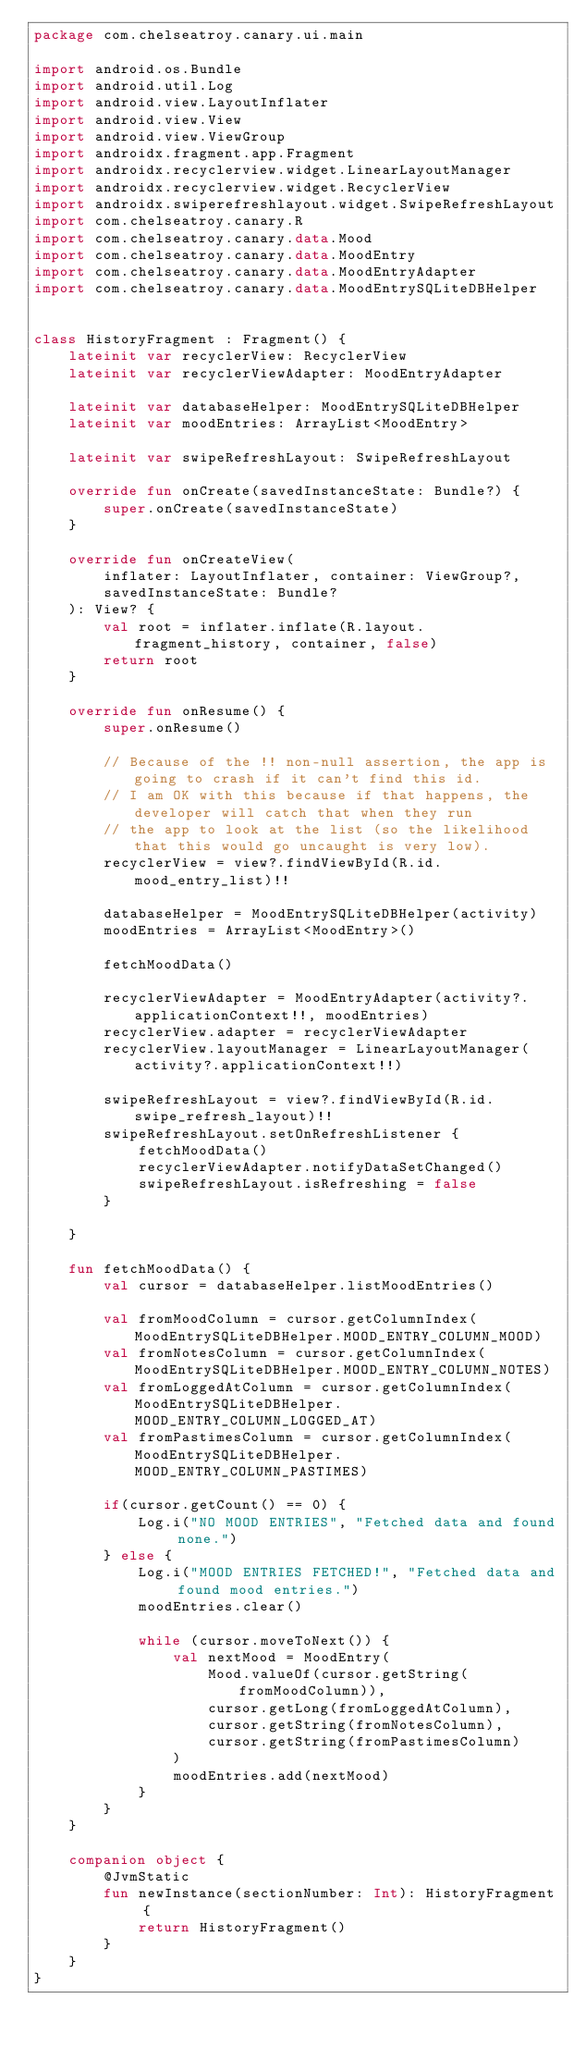<code> <loc_0><loc_0><loc_500><loc_500><_Kotlin_>package com.chelseatroy.canary.ui.main

import android.os.Bundle
import android.util.Log
import android.view.LayoutInflater
import android.view.View
import android.view.ViewGroup
import androidx.fragment.app.Fragment
import androidx.recyclerview.widget.LinearLayoutManager
import androidx.recyclerview.widget.RecyclerView
import androidx.swiperefreshlayout.widget.SwipeRefreshLayout
import com.chelseatroy.canary.R
import com.chelseatroy.canary.data.Mood
import com.chelseatroy.canary.data.MoodEntry
import com.chelseatroy.canary.data.MoodEntryAdapter
import com.chelseatroy.canary.data.MoodEntrySQLiteDBHelper


class HistoryFragment : Fragment() {
    lateinit var recyclerView: RecyclerView
    lateinit var recyclerViewAdapter: MoodEntryAdapter

    lateinit var databaseHelper: MoodEntrySQLiteDBHelper
    lateinit var moodEntries: ArrayList<MoodEntry>

    lateinit var swipeRefreshLayout: SwipeRefreshLayout

    override fun onCreate(savedInstanceState: Bundle?) {
        super.onCreate(savedInstanceState)
    }

    override fun onCreateView(
        inflater: LayoutInflater, container: ViewGroup?,
        savedInstanceState: Bundle?
    ): View? {
        val root = inflater.inflate(R.layout.fragment_history, container, false)
        return root
    }

    override fun onResume() {
        super.onResume()

        // Because of the !! non-null assertion, the app is going to crash if it can't find this id.
        // I am OK with this because if that happens, the developer will catch that when they run
        // the app to look at the list (so the likelihood that this would go uncaught is very low).
        recyclerView = view?.findViewById(R.id.mood_entry_list)!!

        databaseHelper = MoodEntrySQLiteDBHelper(activity)
        moodEntries = ArrayList<MoodEntry>()

        fetchMoodData()

        recyclerViewAdapter = MoodEntryAdapter(activity?.applicationContext!!, moodEntries)
        recyclerView.adapter = recyclerViewAdapter
        recyclerView.layoutManager = LinearLayoutManager(activity?.applicationContext!!)

        swipeRefreshLayout = view?.findViewById(R.id.swipe_refresh_layout)!!
        swipeRefreshLayout.setOnRefreshListener {
            fetchMoodData()
            recyclerViewAdapter.notifyDataSetChanged()
            swipeRefreshLayout.isRefreshing = false
        }

    }

    fun fetchMoodData() {
        val cursor = databaseHelper.listMoodEntries()

        val fromMoodColumn = cursor.getColumnIndex(MoodEntrySQLiteDBHelper.MOOD_ENTRY_COLUMN_MOOD)
        val fromNotesColumn = cursor.getColumnIndex(MoodEntrySQLiteDBHelper.MOOD_ENTRY_COLUMN_NOTES)
        val fromLoggedAtColumn = cursor.getColumnIndex(MoodEntrySQLiteDBHelper.MOOD_ENTRY_COLUMN_LOGGED_AT)
        val fromPastimesColumn = cursor.getColumnIndex(MoodEntrySQLiteDBHelper.MOOD_ENTRY_COLUMN_PASTIMES)

        if(cursor.getCount() == 0) {
            Log.i("NO MOOD ENTRIES", "Fetched data and found none.")
        } else {
            Log.i("MOOD ENTRIES FETCHED!", "Fetched data and found mood entries.")
            moodEntries.clear()

            while (cursor.moveToNext()) {
                val nextMood = MoodEntry(
                    Mood.valueOf(cursor.getString(fromMoodColumn)),
                    cursor.getLong(fromLoggedAtColumn),
                    cursor.getString(fromNotesColumn),
                    cursor.getString(fromPastimesColumn)
                )
                moodEntries.add(nextMood)
            }
        }
    }

    companion object {
        @JvmStatic
        fun newInstance(sectionNumber: Int): HistoryFragment {
            return HistoryFragment()
        }
    }
}</code> 